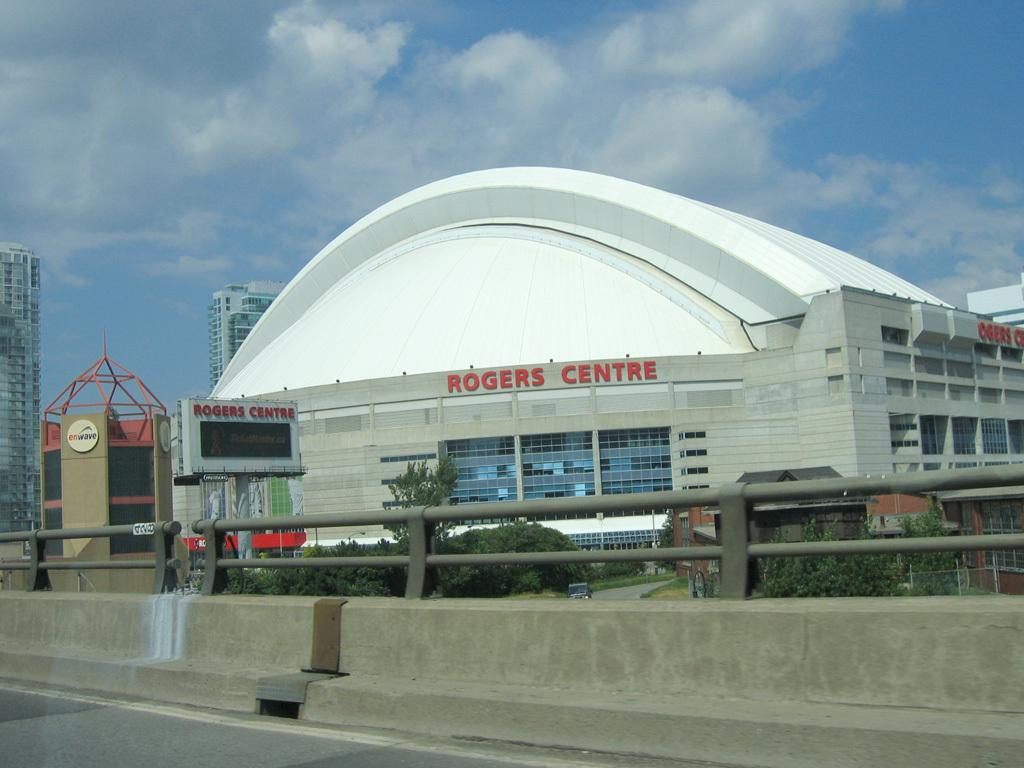What can be seen at the front of the image? There are railings in front of the image. What is on the road in the image? There is a vehicle on the road. What type of natural elements are present in the image? There are trees in the image. What type of man-made structures can be seen in the image? There are buildings in the image. What information might be displayed on the board in the image? There is a display board in the image, which could display information or advertisements. What is visible in the sky at the top of the image? There are clouds in the sky at the top of the image. How many boys are playing with shoes on the mountain in the image? There are no boys or shoes on a mountain in the image; the image features railings, a vehicle, trees, buildings, a display board, and clouds in the sky. 